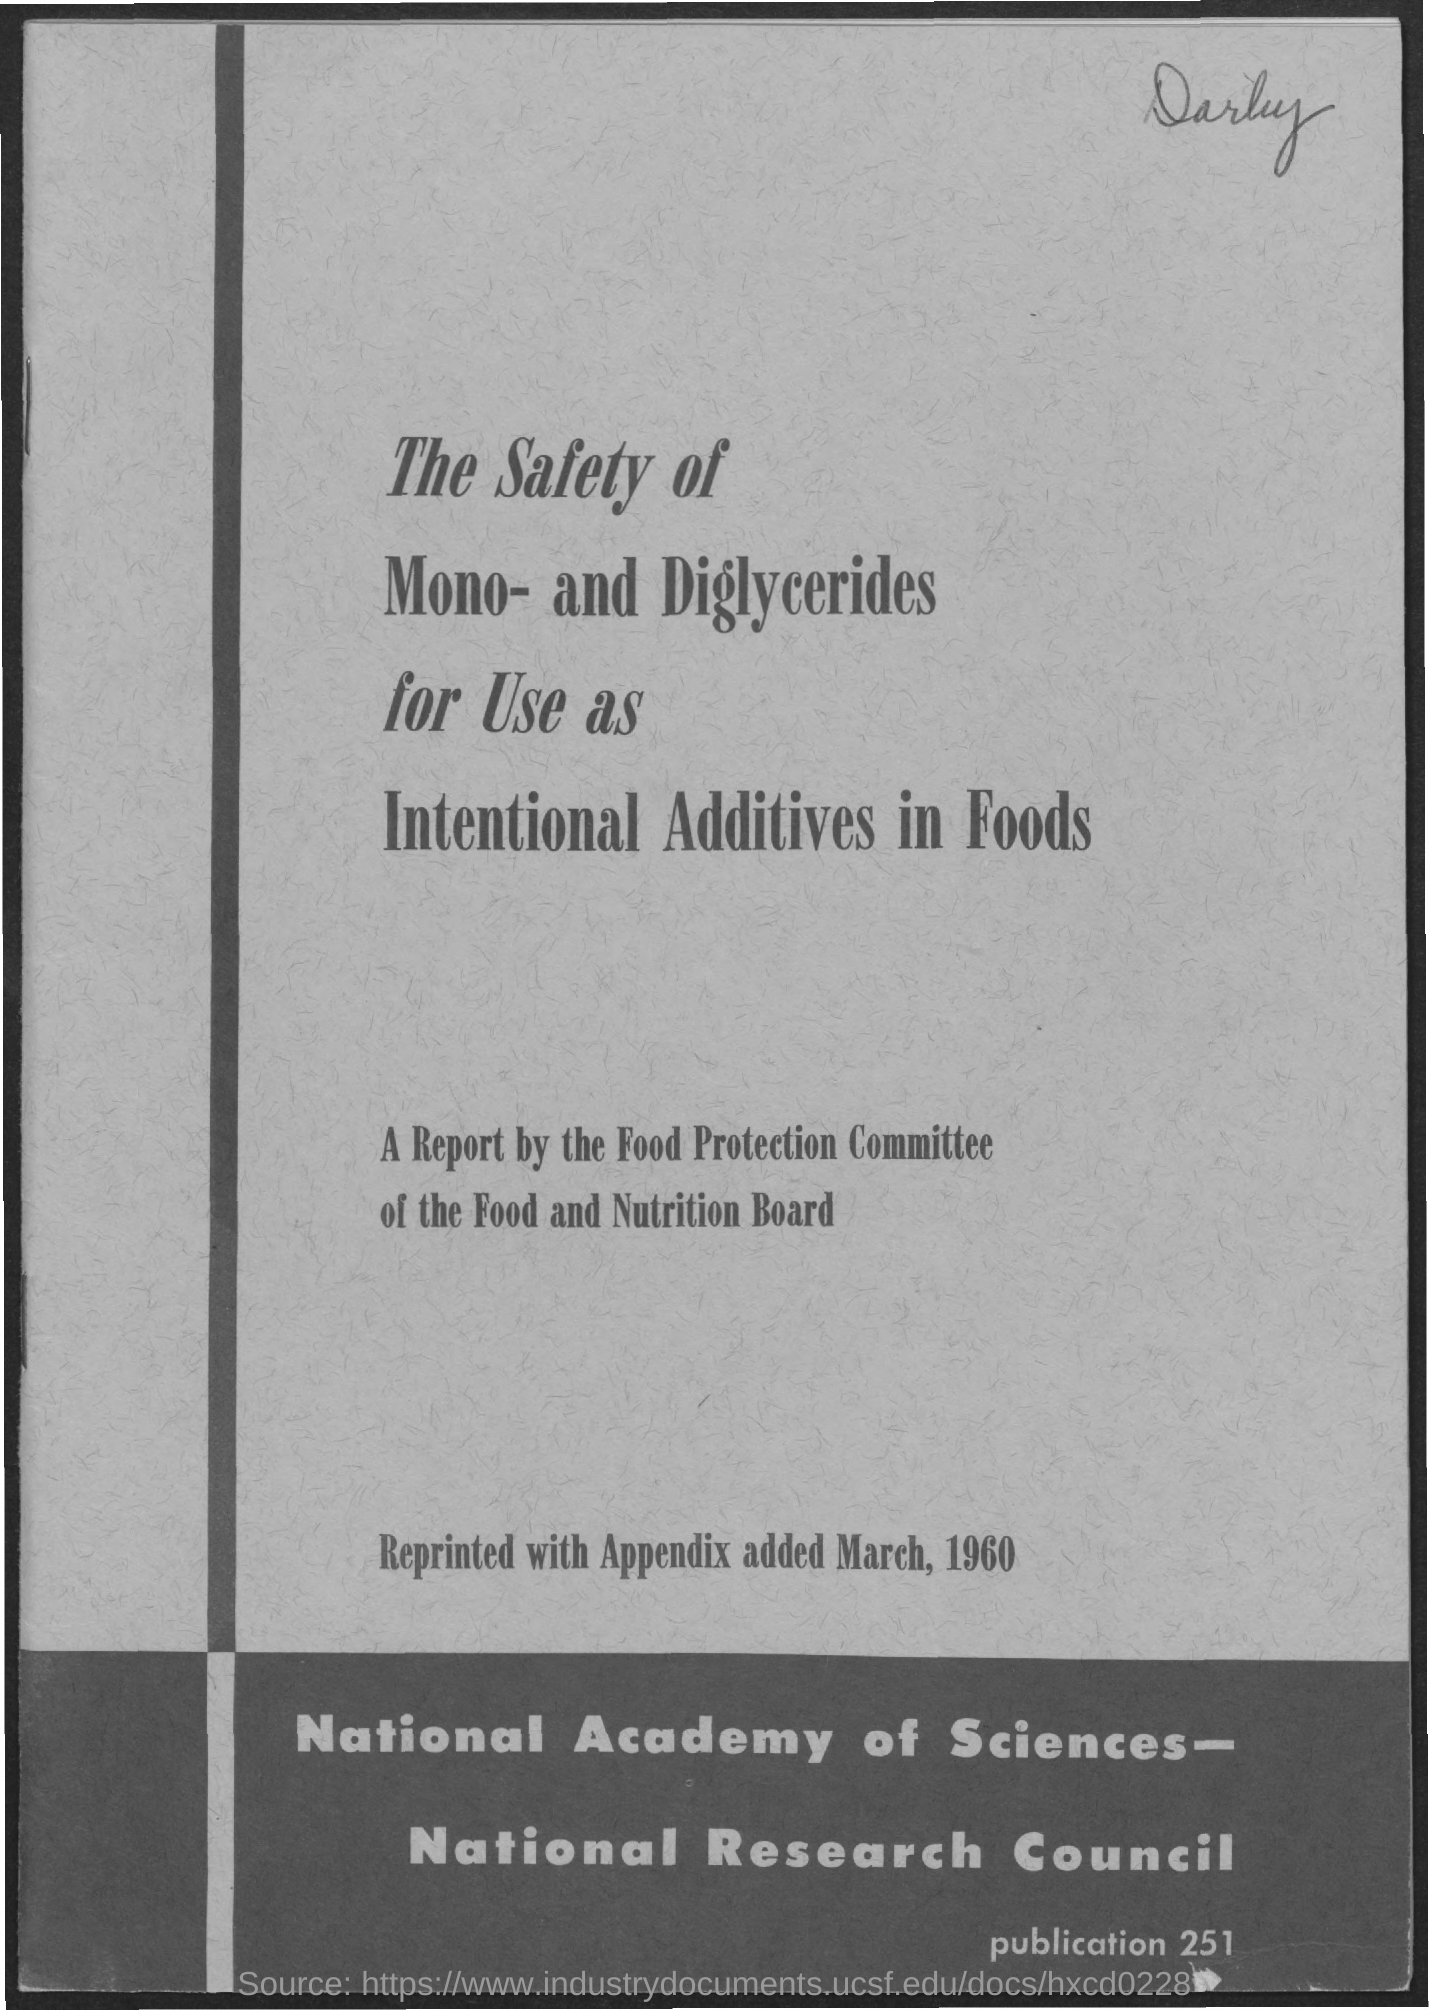Give some essential details in this illustration. The safety of mono- and diglycerides as intentional additives in foods has been established through extensive research and testing. These compounds are commonly used as emulsifiers in a variety of food products to improve texture and shelf life. However, it is important to note that excessive consumption of these additives may have adverse effects on human health. The reprint of the article, which included an appendix, was done in March, 1960. 